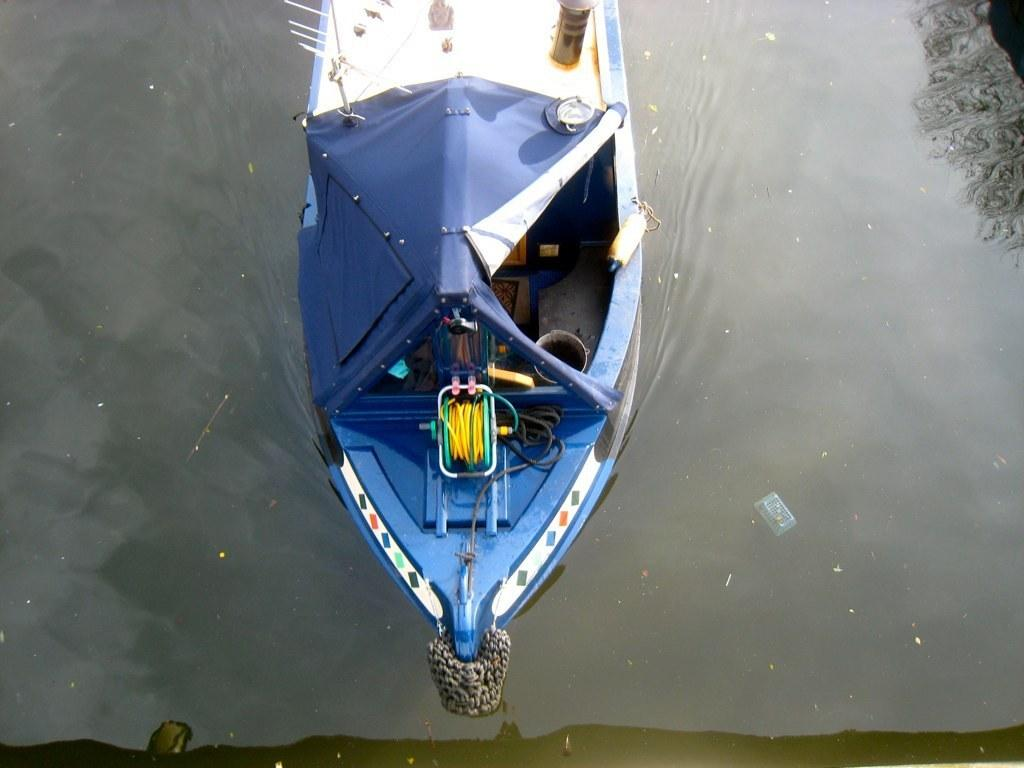What is the main subject of the image? The main subject of the image is a ship. Can you describe the water in the image? There are dust particles in the water in the image. What type of feast is being prepared on the ship in the image? There is no indication of a feast being prepared on the ship in the image. 